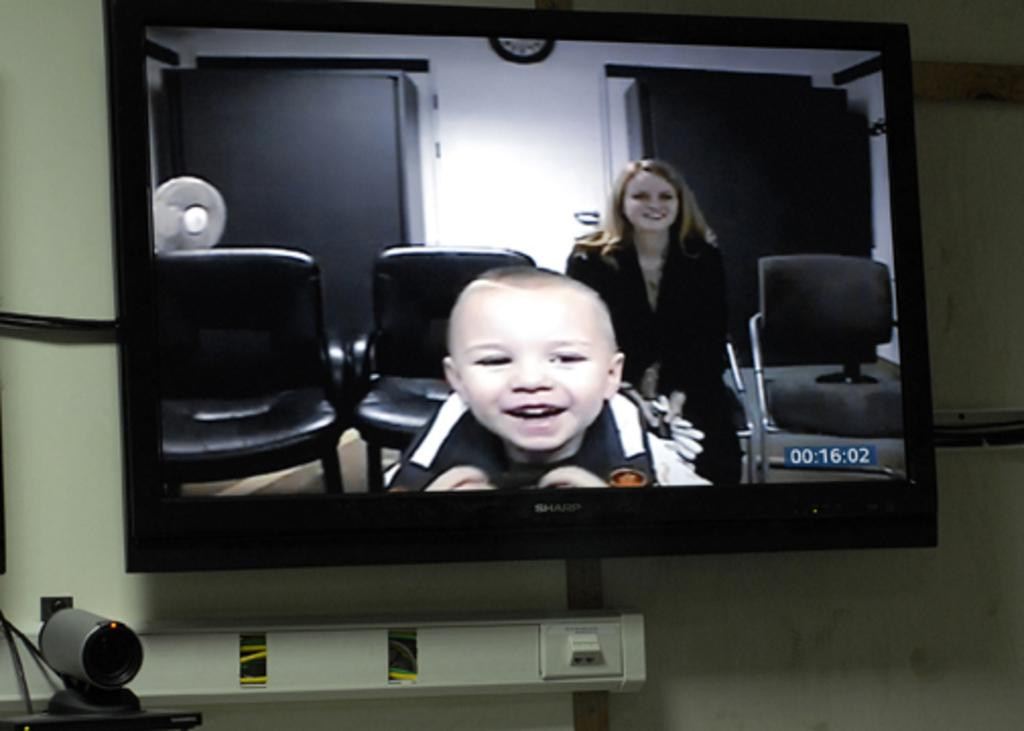What electronic device is visible in the image? There is a television in the image. What other electronic device can be seen in the image? There is a camera in the image. Are there any wires visible in the image? Yes, there are wires in the image. What is being displayed on the television? The television is displaying chairs, a clock, a fan, a woman, and a child smiling. Where is the vase located in the image? There is no vase present in the image. How many passengers are visible in the image? There are no passengers visible in the image. 